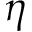Convert formula to latex. <formula><loc_0><loc_0><loc_500><loc_500>\eta</formula> 